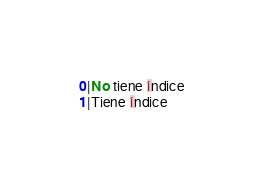Convert code to text. <code><loc_0><loc_0><loc_500><loc_500><_SQL_>0|No tiene índice
1|Tiene índice
</code> 